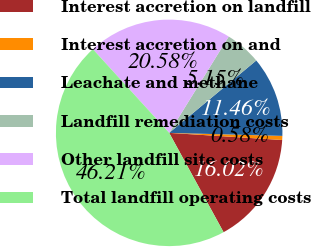Convert chart to OTSL. <chart><loc_0><loc_0><loc_500><loc_500><pie_chart><fcel>Interest accretion on landfill<fcel>Interest accretion on and<fcel>Leachate and methane<fcel>Landfill remediation costs<fcel>Other landfill site costs<fcel>Total landfill operating costs<nl><fcel>16.02%<fcel>0.58%<fcel>11.46%<fcel>5.15%<fcel>20.58%<fcel>46.21%<nl></chart> 